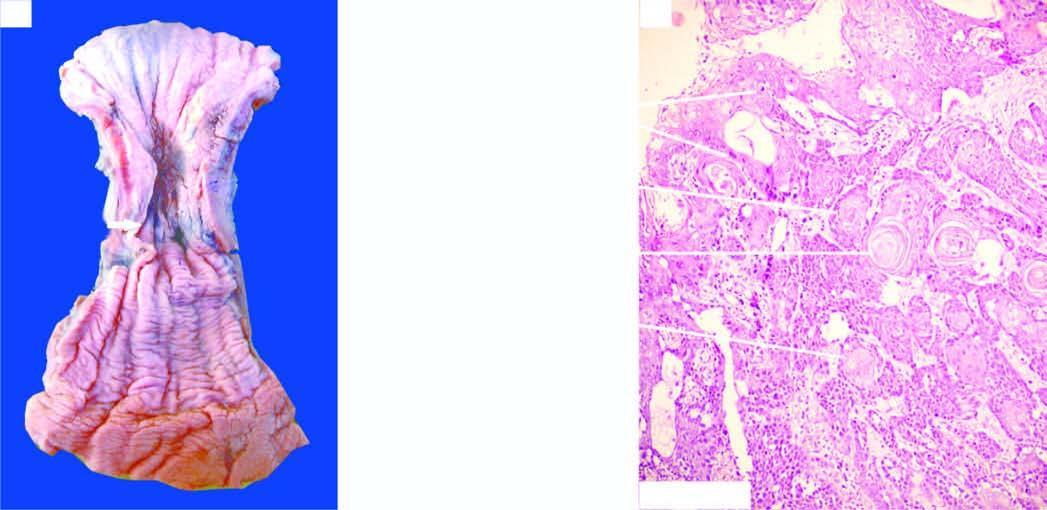s the mucosal surface ulcerated?
Answer the question using a single word or phrase. Yes 